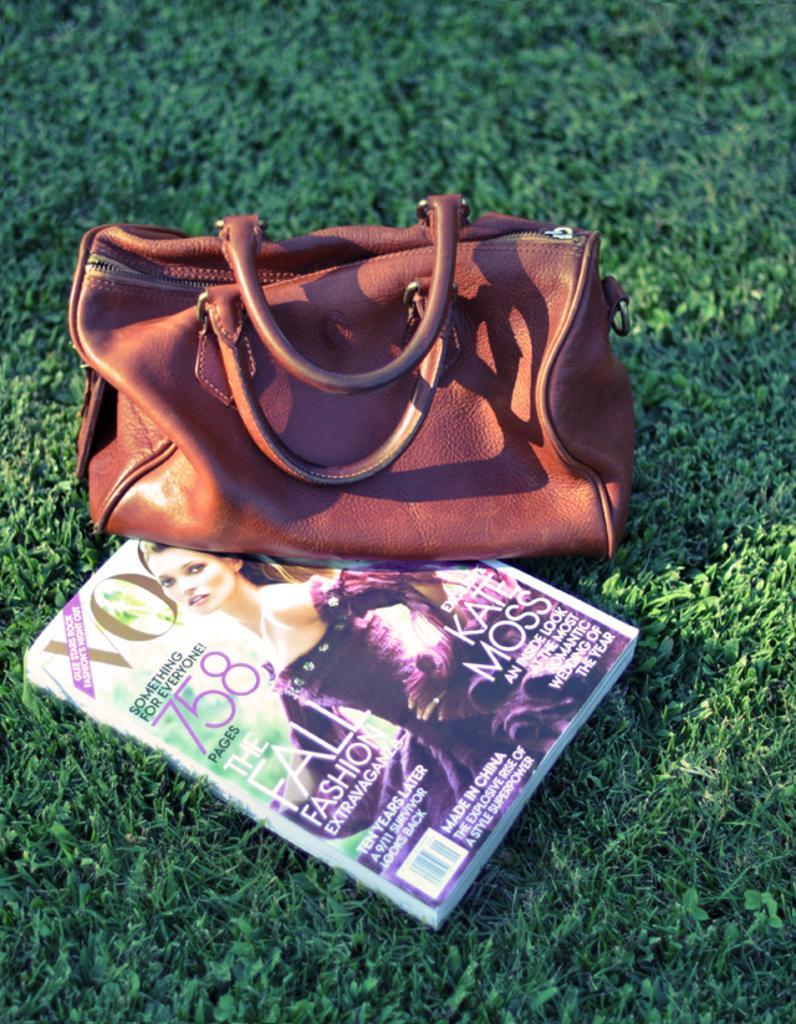Can you describe this image briefly? In this picture there is a brown handbag and a magazine on the grass. On magazine there is a woman wearing a purple dress. 